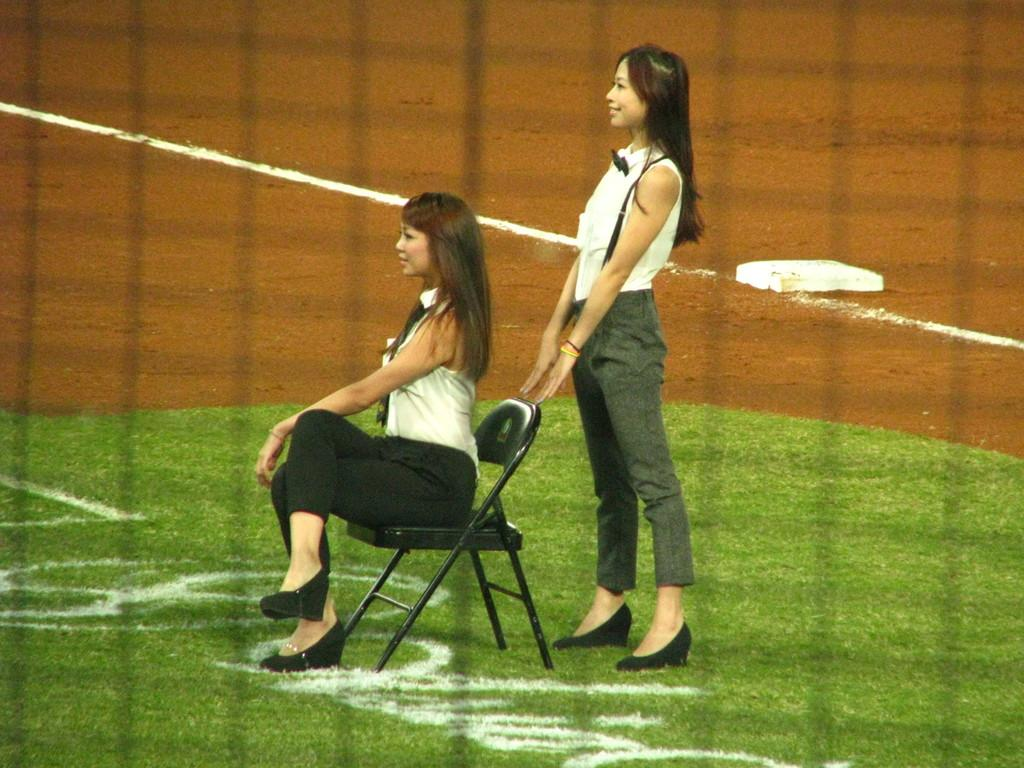How many women are in the image? There are two women in the image. What is the position of one of the women? One woman is sitting on a chair. What is the position of the other woman? The other woman is standing on the ground. What type of calendar is the woman holding in the image? There is no calendar present in the image. What kind of powder is the woman sprinkling on the instrument in the image? There is no powder or instrument present in the image. 